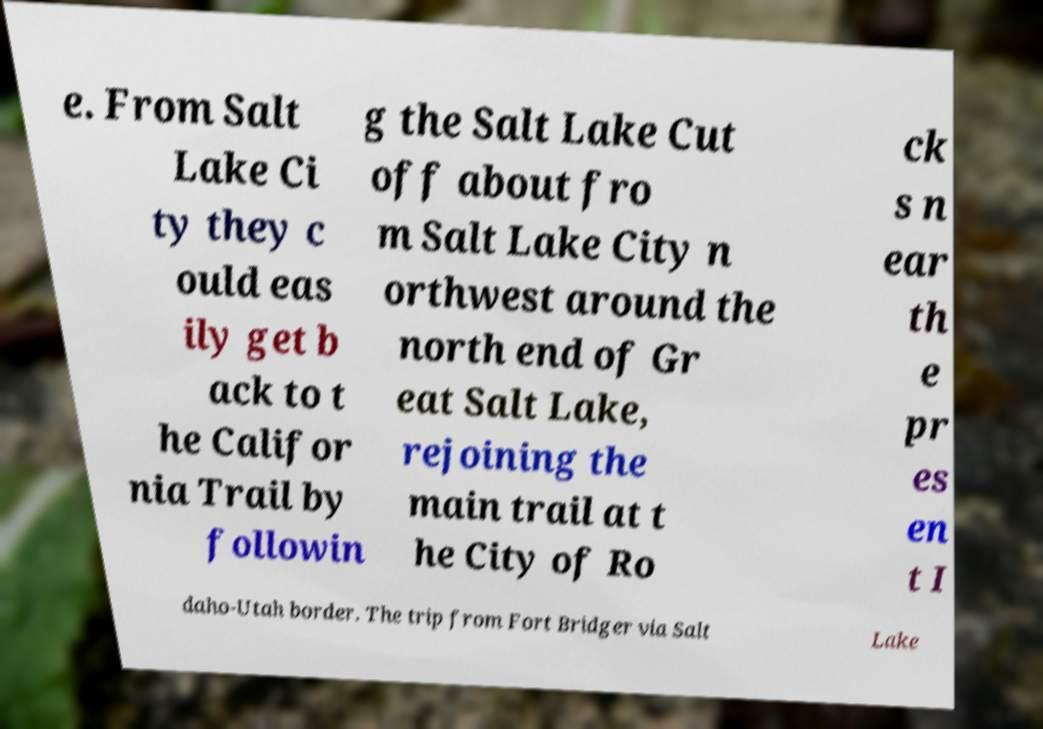I need the written content from this picture converted into text. Can you do that? e. From Salt Lake Ci ty they c ould eas ily get b ack to t he Califor nia Trail by followin g the Salt Lake Cut off about fro m Salt Lake City n orthwest around the north end of Gr eat Salt Lake, rejoining the main trail at t he City of Ro ck s n ear th e pr es en t I daho-Utah border. The trip from Fort Bridger via Salt Lake 